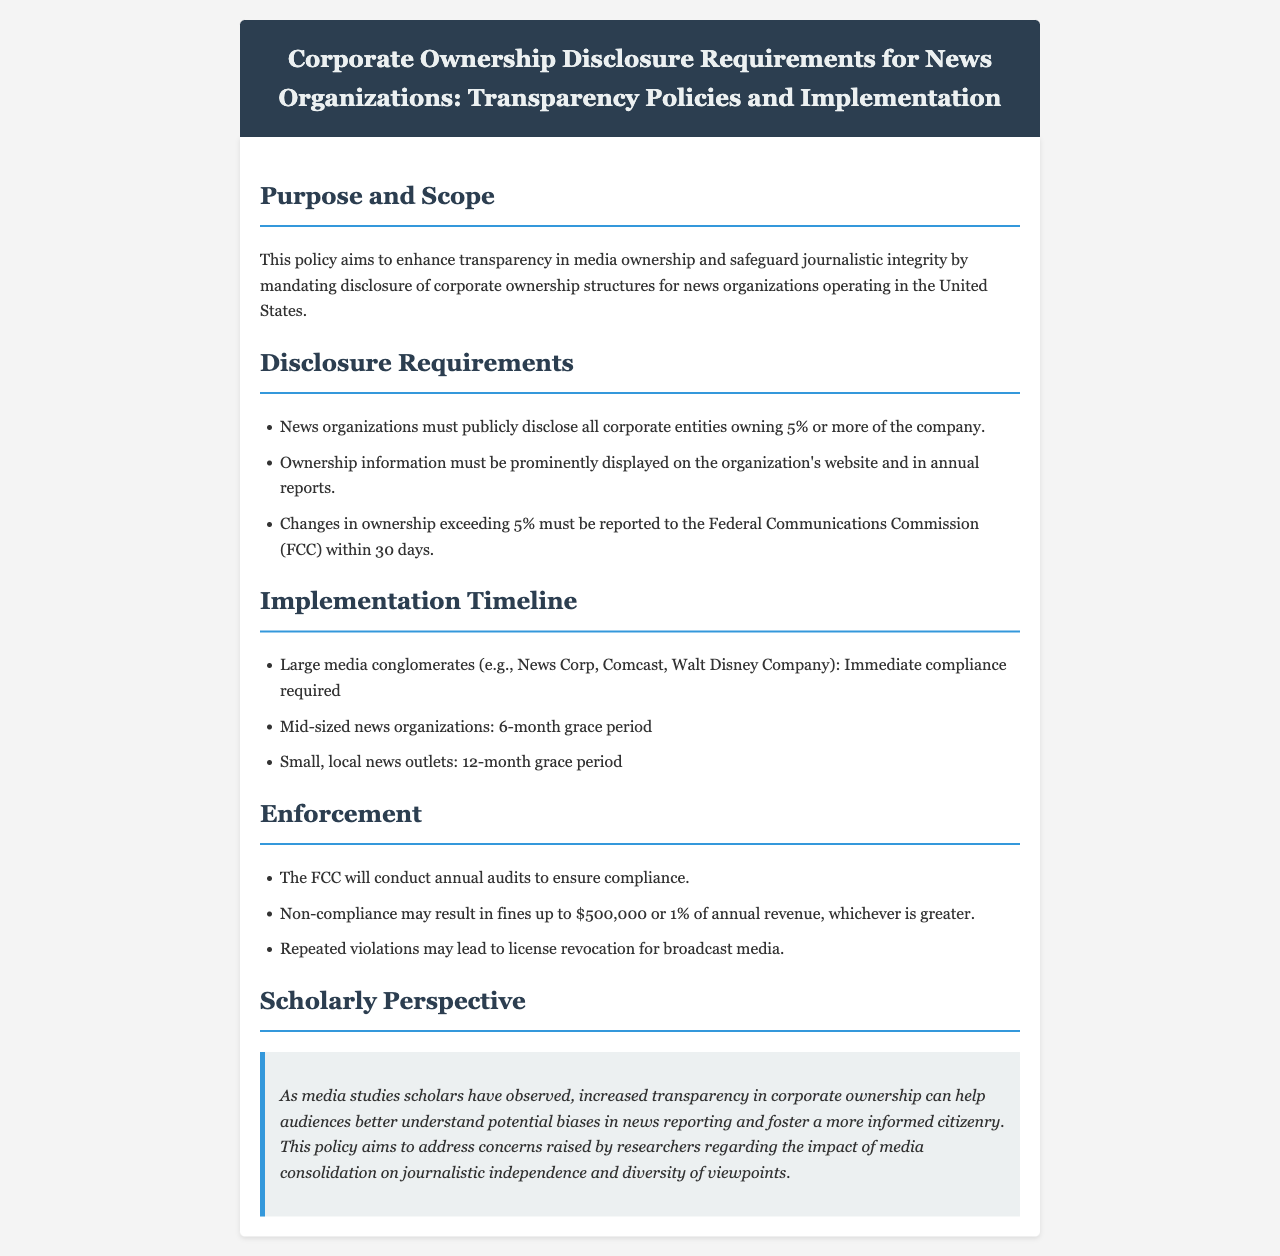What is the purpose of the policy? The purpose stated in the document is to enhance transparency in media ownership and safeguard journalistic integrity.
Answer: Enhance transparency What percentage of ownership must be publicly disclosed? According to the disclosure requirements, ownership of 5% or more must be disclosed.
Answer: 5% What is the grace period for mid-sized news organizations to comply? The document specifies that mid-sized news organizations have a 6-month grace period.
Answer: 6-month grace period What is the maximum fine for non-compliance? The policy states that fines for non-compliance may be up to $500,000 or 1% of annual revenue, whichever is greater.
Answer: $500,000 Who conducts annual audits to ensure compliance? The Federal Communications Commission (FCC) is responsible for conducting annual audits.
Answer: FCC 